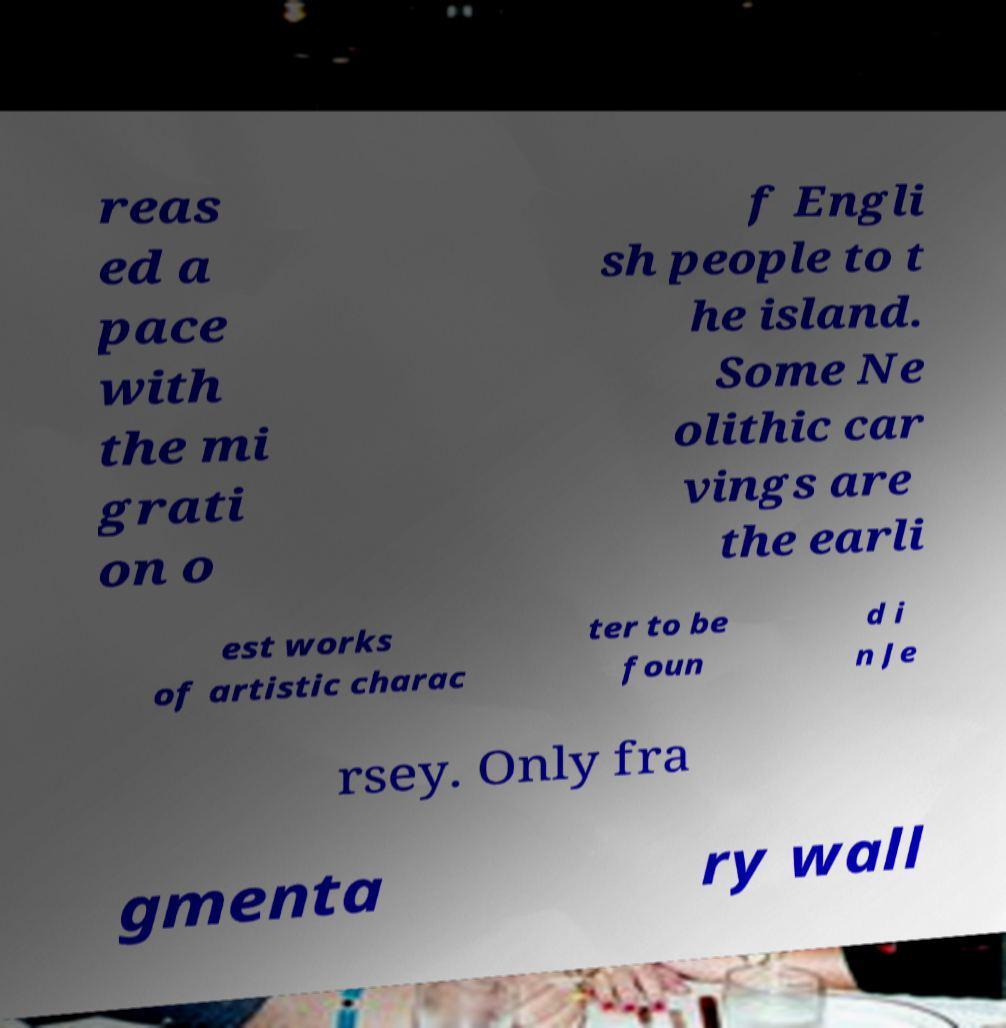Please identify and transcribe the text found in this image. reas ed a pace with the mi grati on o f Engli sh people to t he island. Some Ne olithic car vings are the earli est works of artistic charac ter to be foun d i n Je rsey. Only fra gmenta ry wall 